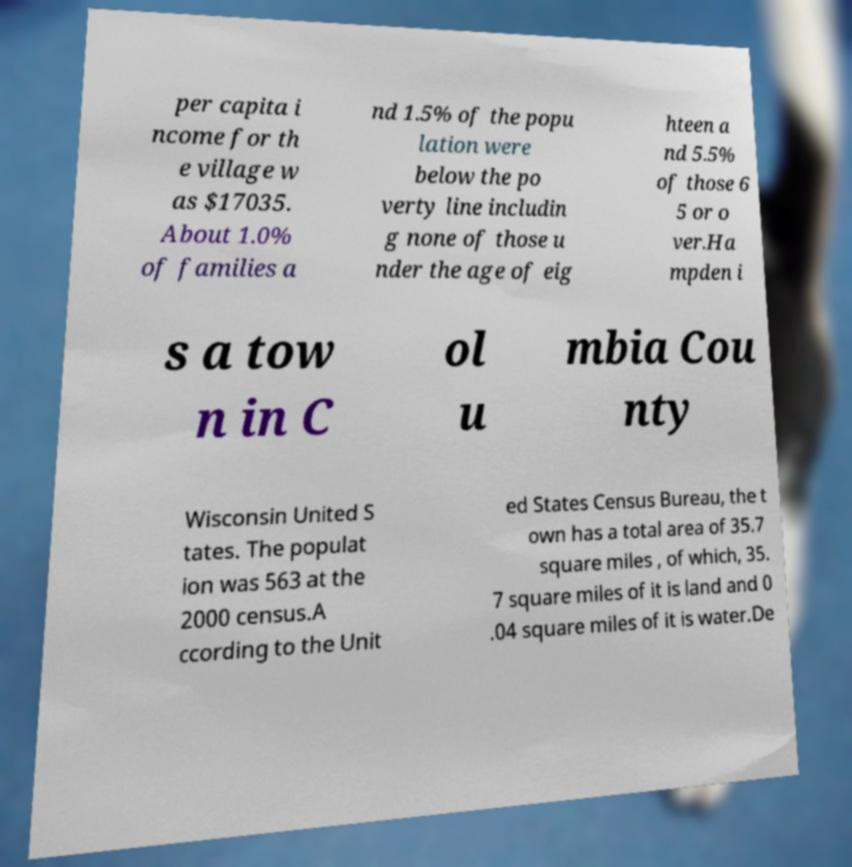What messages or text are displayed in this image? I need them in a readable, typed format. per capita i ncome for th e village w as $17035. About 1.0% of families a nd 1.5% of the popu lation were below the po verty line includin g none of those u nder the age of eig hteen a nd 5.5% of those 6 5 or o ver.Ha mpden i s a tow n in C ol u mbia Cou nty Wisconsin United S tates. The populat ion was 563 at the 2000 census.A ccording to the Unit ed States Census Bureau, the t own has a total area of 35.7 square miles , of which, 35. 7 square miles of it is land and 0 .04 square miles of it is water.De 